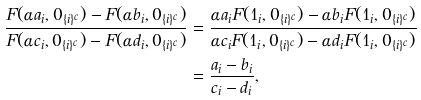Convert formula to latex. <formula><loc_0><loc_0><loc_500><loc_500>\frac { F ( \alpha a _ { i } , 0 _ { \{ i \} ^ { c } } ) - F ( \alpha b _ { i } , 0 _ { \{ i \} ^ { c } } ) } { F ( \alpha c _ { i } , 0 _ { \{ i \} ^ { c } } ) - F ( \alpha d _ { i } , 0 _ { \{ i \} ^ { c } } ) } & = \frac { \alpha a _ { i } F ( 1 _ { i } , 0 _ { \{ i \} ^ { c } } ) - \alpha b _ { i } F ( 1 _ { i } , 0 _ { \{ i \} ^ { c } } ) } { \alpha c _ { i } F ( 1 _ { i } , 0 _ { \{ i \} ^ { c } } ) - \alpha d _ { i } F ( 1 _ { i } , 0 _ { \{ i \} ^ { c } } ) } \\ & = \frac { a _ { i } - b _ { i } } { c _ { i } - d _ { i } } ,</formula> 